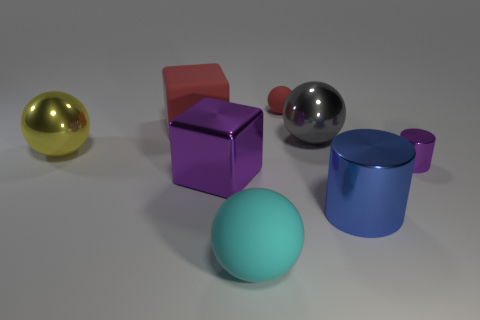Add 2 cyan matte cylinders. How many objects exist? 10 Subtract all cylinders. How many objects are left? 6 Add 6 big purple metallic objects. How many big purple metallic objects exist? 7 Subtract 1 yellow spheres. How many objects are left? 7 Subtract all big shiny spheres. Subtract all small metal cylinders. How many objects are left? 5 Add 6 rubber blocks. How many rubber blocks are left? 7 